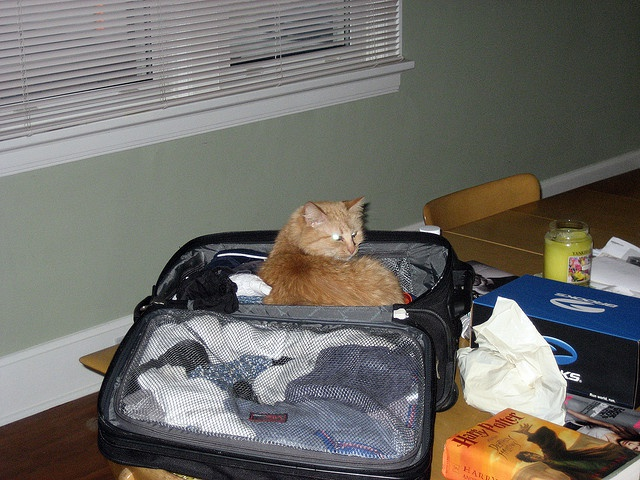Describe the objects in this image and their specific colors. I can see suitcase in darkgray, black, gray, and lightgray tones, cat in darkgray, gray, tan, brown, and maroon tones, book in darkgray, black, red, and orange tones, chair in darkgray, maroon, olive, and black tones, and bottle in darkgray, olive, and black tones in this image. 